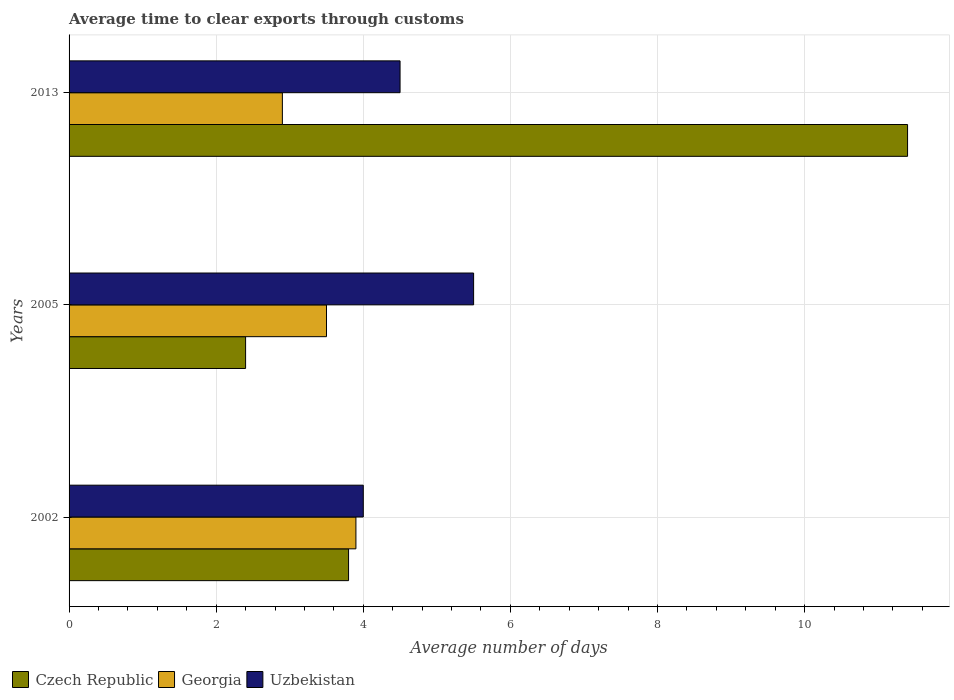How many bars are there on the 1st tick from the top?
Provide a succinct answer. 3. How many bars are there on the 3rd tick from the bottom?
Provide a succinct answer. 3. What is the average number of days required to clear exports through customs in Uzbekistan in 2002?
Make the answer very short. 4. Across all years, what is the maximum average number of days required to clear exports through customs in Uzbekistan?
Provide a succinct answer. 5.5. Across all years, what is the minimum average number of days required to clear exports through customs in Czech Republic?
Make the answer very short. 2.4. What is the total average number of days required to clear exports through customs in Uzbekistan in the graph?
Your response must be concise. 14. What is the difference between the average number of days required to clear exports through customs in Uzbekistan in 2002 and that in 2005?
Offer a terse response. -1.5. What is the average average number of days required to clear exports through customs in Uzbekistan per year?
Keep it short and to the point. 4.67. In how many years, is the average number of days required to clear exports through customs in Czech Republic greater than 0.4 days?
Keep it short and to the point. 3. What is the ratio of the average number of days required to clear exports through customs in Czech Republic in 2005 to that in 2013?
Give a very brief answer. 0.21. Is the average number of days required to clear exports through customs in Czech Republic in 2002 less than that in 2005?
Ensure brevity in your answer.  No. What is the difference between the highest and the second highest average number of days required to clear exports through customs in Georgia?
Provide a short and direct response. 0.4. What is the difference between the highest and the lowest average number of days required to clear exports through customs in Georgia?
Your answer should be very brief. 1. What does the 2nd bar from the top in 2002 represents?
Keep it short and to the point. Georgia. What does the 1st bar from the bottom in 2013 represents?
Keep it short and to the point. Czech Republic. Are all the bars in the graph horizontal?
Provide a short and direct response. Yes. How many years are there in the graph?
Provide a short and direct response. 3. Does the graph contain grids?
Provide a succinct answer. Yes. Where does the legend appear in the graph?
Offer a very short reply. Bottom left. How are the legend labels stacked?
Your answer should be compact. Horizontal. What is the title of the graph?
Keep it short and to the point. Average time to clear exports through customs. What is the label or title of the X-axis?
Offer a very short reply. Average number of days. What is the label or title of the Y-axis?
Provide a succinct answer. Years. What is the Average number of days in Uzbekistan in 2005?
Make the answer very short. 5.5. Across all years, what is the maximum Average number of days in Georgia?
Your response must be concise. 3.9. Across all years, what is the maximum Average number of days in Uzbekistan?
Your answer should be compact. 5.5. Across all years, what is the minimum Average number of days in Georgia?
Your response must be concise. 2.9. Across all years, what is the minimum Average number of days of Uzbekistan?
Your answer should be compact. 4. What is the total Average number of days of Georgia in the graph?
Ensure brevity in your answer.  10.3. What is the total Average number of days in Uzbekistan in the graph?
Provide a short and direct response. 14. What is the difference between the Average number of days in Czech Republic in 2002 and that in 2005?
Offer a very short reply. 1.4. What is the difference between the Average number of days in Uzbekistan in 2002 and that in 2005?
Offer a terse response. -1.5. What is the difference between the Average number of days of Czech Republic in 2002 and that in 2013?
Make the answer very short. -7.6. What is the difference between the Average number of days of Georgia in 2005 and that in 2013?
Your response must be concise. 0.6. What is the difference between the Average number of days in Czech Republic in 2002 and the Average number of days in Georgia in 2005?
Keep it short and to the point. 0.3. What is the difference between the Average number of days of Czech Republic in 2002 and the Average number of days of Uzbekistan in 2005?
Your answer should be very brief. -1.7. What is the difference between the Average number of days of Georgia in 2002 and the Average number of days of Uzbekistan in 2005?
Provide a short and direct response. -1.6. What is the difference between the Average number of days of Czech Republic in 2002 and the Average number of days of Georgia in 2013?
Offer a very short reply. 0.9. What is the difference between the Average number of days of Czech Republic in 2005 and the Average number of days of Georgia in 2013?
Your answer should be compact. -0.5. What is the difference between the Average number of days of Czech Republic in 2005 and the Average number of days of Uzbekistan in 2013?
Your answer should be very brief. -2.1. What is the difference between the Average number of days in Georgia in 2005 and the Average number of days in Uzbekistan in 2013?
Your answer should be very brief. -1. What is the average Average number of days of Czech Republic per year?
Make the answer very short. 5.87. What is the average Average number of days of Georgia per year?
Your answer should be compact. 3.43. What is the average Average number of days of Uzbekistan per year?
Provide a short and direct response. 4.67. In the year 2002, what is the difference between the Average number of days of Czech Republic and Average number of days of Uzbekistan?
Your response must be concise. -0.2. In the year 2002, what is the difference between the Average number of days in Georgia and Average number of days in Uzbekistan?
Provide a succinct answer. -0.1. In the year 2005, what is the difference between the Average number of days of Georgia and Average number of days of Uzbekistan?
Offer a terse response. -2. In the year 2013, what is the difference between the Average number of days in Czech Republic and Average number of days in Georgia?
Your answer should be very brief. 8.5. In the year 2013, what is the difference between the Average number of days of Georgia and Average number of days of Uzbekistan?
Keep it short and to the point. -1.6. What is the ratio of the Average number of days in Czech Republic in 2002 to that in 2005?
Offer a terse response. 1.58. What is the ratio of the Average number of days of Georgia in 2002 to that in 2005?
Provide a short and direct response. 1.11. What is the ratio of the Average number of days in Uzbekistan in 2002 to that in 2005?
Your response must be concise. 0.73. What is the ratio of the Average number of days of Georgia in 2002 to that in 2013?
Offer a very short reply. 1.34. What is the ratio of the Average number of days in Czech Republic in 2005 to that in 2013?
Give a very brief answer. 0.21. What is the ratio of the Average number of days in Georgia in 2005 to that in 2013?
Your response must be concise. 1.21. What is the ratio of the Average number of days in Uzbekistan in 2005 to that in 2013?
Provide a short and direct response. 1.22. What is the difference between the highest and the second highest Average number of days of Czech Republic?
Make the answer very short. 7.6. What is the difference between the highest and the second highest Average number of days of Uzbekistan?
Offer a terse response. 1. What is the difference between the highest and the lowest Average number of days in Czech Republic?
Keep it short and to the point. 9. What is the difference between the highest and the lowest Average number of days in Uzbekistan?
Keep it short and to the point. 1.5. 